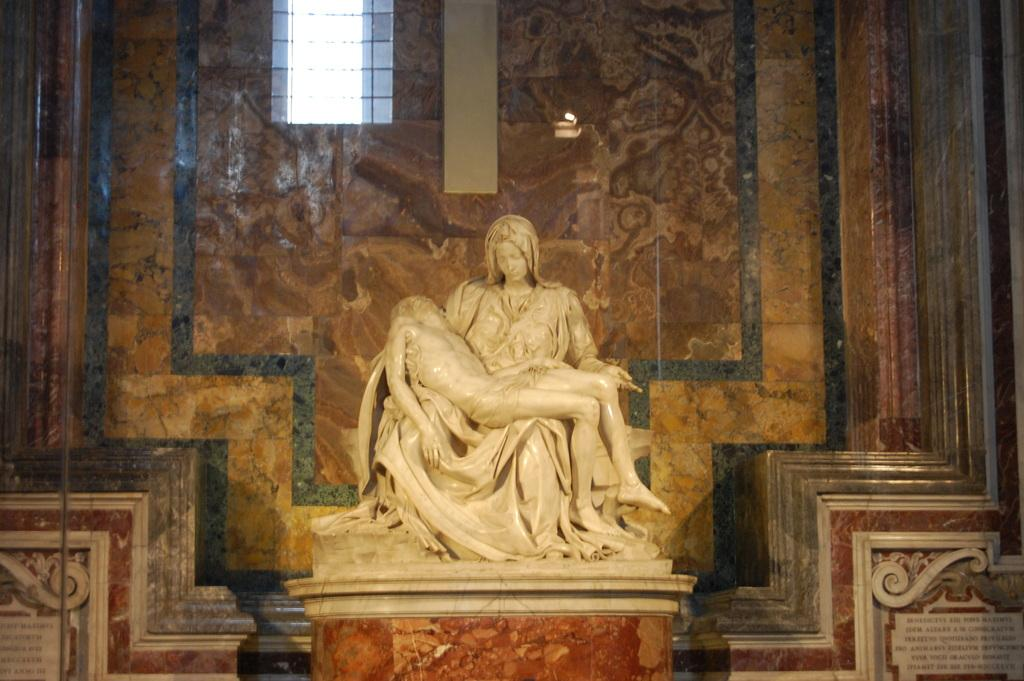What is: What is the main subject of the image? There is a statue of a woman in the image. What is the woman in the statue doing? The woman is sitting and holding a person. What can be seen in the background of the image? There is a window at the back of the image. Are there any words or letters visible in the image? Yes, there is text on the wall at the bottom left and bottom right of the image. Can you see a boat in the image? No, there is no boat present in the image. How many deer are visible in the image? There are no deer present in the image. 